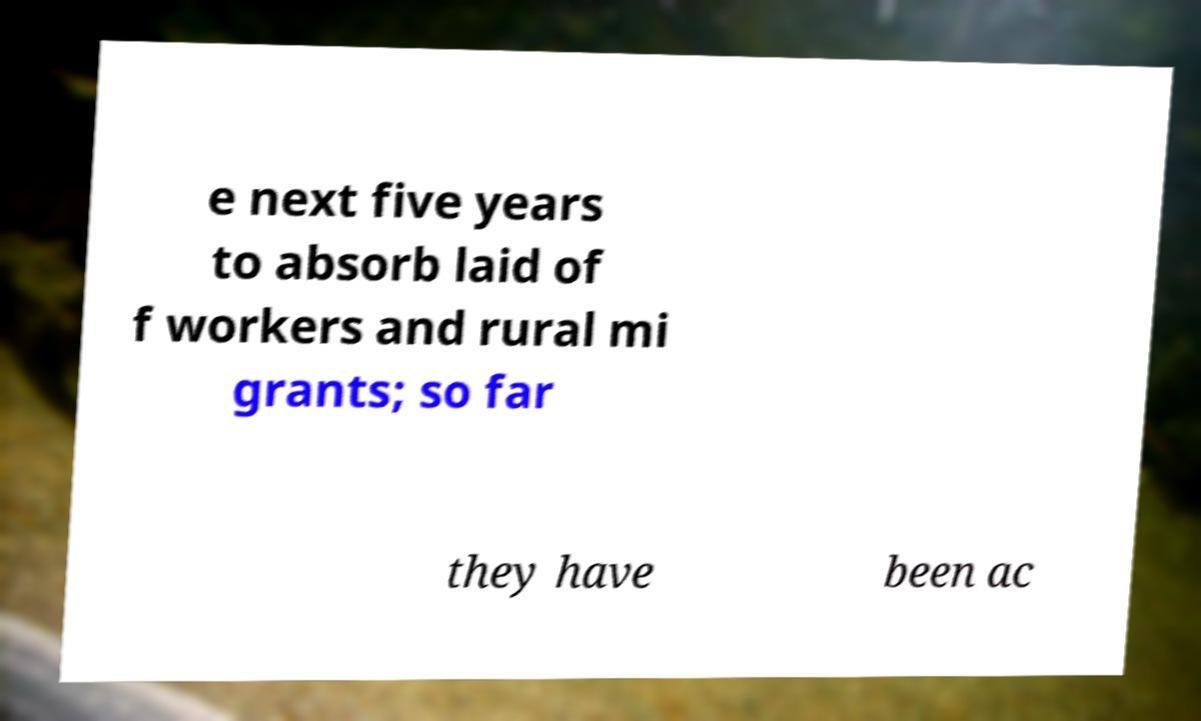Please read and relay the text visible in this image. What does it say? e next five years to absorb laid of f workers and rural mi grants; so far they have been ac 